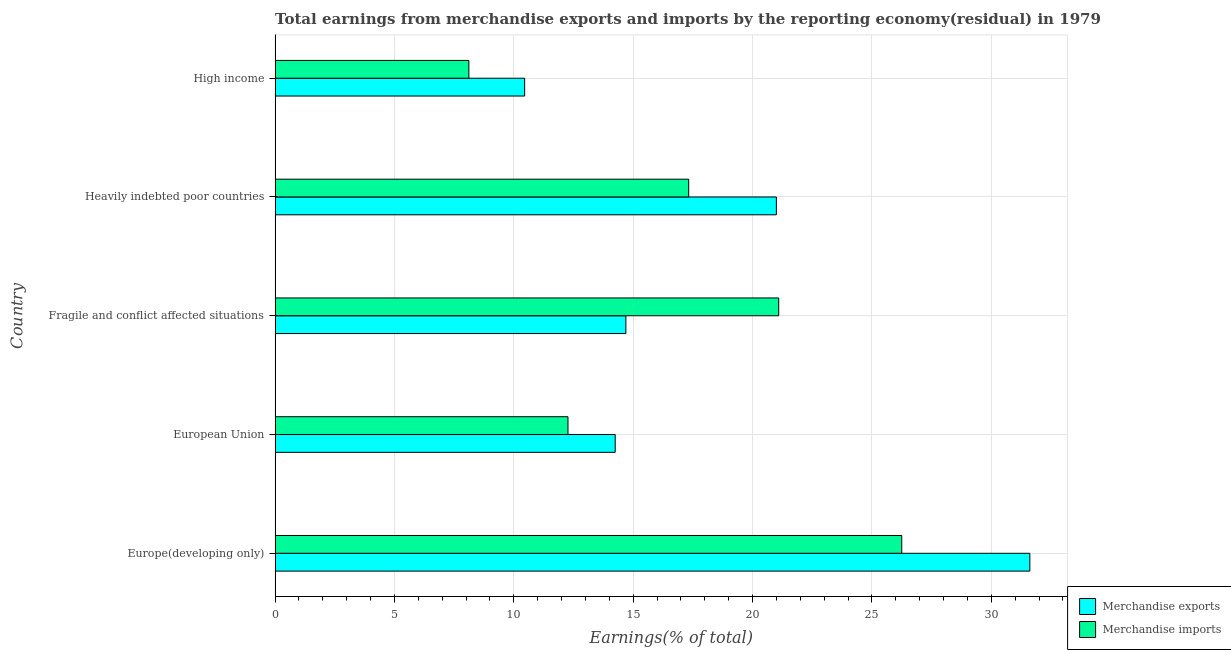How many groups of bars are there?
Offer a very short reply. 5. How many bars are there on the 2nd tick from the top?
Your answer should be compact. 2. How many bars are there on the 3rd tick from the bottom?
Ensure brevity in your answer.  2. What is the label of the 3rd group of bars from the top?
Your answer should be compact. Fragile and conflict affected situations. What is the earnings from merchandise exports in Heavily indebted poor countries?
Provide a succinct answer. 21. Across all countries, what is the maximum earnings from merchandise exports?
Your response must be concise. 31.62. Across all countries, what is the minimum earnings from merchandise exports?
Your answer should be very brief. 10.45. In which country was the earnings from merchandise exports maximum?
Ensure brevity in your answer.  Europe(developing only). What is the total earnings from merchandise imports in the graph?
Your answer should be very brief. 85.06. What is the difference between the earnings from merchandise exports in European Union and that in Heavily indebted poor countries?
Keep it short and to the point. -6.75. What is the difference between the earnings from merchandise exports in High income and the earnings from merchandise imports in Fragile and conflict affected situations?
Your answer should be compact. -10.64. What is the average earnings from merchandise imports per country?
Offer a very short reply. 17.01. What is the difference between the earnings from merchandise exports and earnings from merchandise imports in European Union?
Provide a succinct answer. 1.98. What is the ratio of the earnings from merchandise imports in Europe(developing only) to that in European Union?
Your response must be concise. 2.14. What is the difference between the highest and the second highest earnings from merchandise exports?
Provide a succinct answer. 10.62. What is the difference between the highest and the lowest earnings from merchandise imports?
Ensure brevity in your answer.  18.13. How many countries are there in the graph?
Make the answer very short. 5. Are the values on the major ticks of X-axis written in scientific E-notation?
Provide a succinct answer. No. How are the legend labels stacked?
Offer a very short reply. Vertical. What is the title of the graph?
Make the answer very short. Total earnings from merchandise exports and imports by the reporting economy(residual) in 1979. Does "Electricity" appear as one of the legend labels in the graph?
Give a very brief answer. No. What is the label or title of the X-axis?
Your answer should be compact. Earnings(% of total). What is the Earnings(% of total) of Merchandise exports in Europe(developing only)?
Your answer should be very brief. 31.62. What is the Earnings(% of total) in Merchandise imports in Europe(developing only)?
Your answer should be very brief. 26.25. What is the Earnings(% of total) of Merchandise exports in European Union?
Give a very brief answer. 14.25. What is the Earnings(% of total) in Merchandise imports in European Union?
Your answer should be compact. 12.27. What is the Earnings(% of total) in Merchandise exports in Fragile and conflict affected situations?
Keep it short and to the point. 14.69. What is the Earnings(% of total) of Merchandise imports in Fragile and conflict affected situations?
Your answer should be compact. 21.1. What is the Earnings(% of total) of Merchandise exports in Heavily indebted poor countries?
Offer a terse response. 21. What is the Earnings(% of total) in Merchandise imports in Heavily indebted poor countries?
Offer a terse response. 17.33. What is the Earnings(% of total) in Merchandise exports in High income?
Keep it short and to the point. 10.45. What is the Earnings(% of total) in Merchandise imports in High income?
Ensure brevity in your answer.  8.12. Across all countries, what is the maximum Earnings(% of total) of Merchandise exports?
Your response must be concise. 31.62. Across all countries, what is the maximum Earnings(% of total) in Merchandise imports?
Keep it short and to the point. 26.25. Across all countries, what is the minimum Earnings(% of total) in Merchandise exports?
Keep it short and to the point. 10.45. Across all countries, what is the minimum Earnings(% of total) of Merchandise imports?
Keep it short and to the point. 8.12. What is the total Earnings(% of total) in Merchandise exports in the graph?
Keep it short and to the point. 92.01. What is the total Earnings(% of total) of Merchandise imports in the graph?
Your answer should be compact. 85.06. What is the difference between the Earnings(% of total) in Merchandise exports in Europe(developing only) and that in European Union?
Your response must be concise. 17.37. What is the difference between the Earnings(% of total) in Merchandise imports in Europe(developing only) and that in European Union?
Provide a succinct answer. 13.98. What is the difference between the Earnings(% of total) of Merchandise exports in Europe(developing only) and that in Fragile and conflict affected situations?
Your response must be concise. 16.92. What is the difference between the Earnings(% of total) of Merchandise imports in Europe(developing only) and that in Fragile and conflict affected situations?
Keep it short and to the point. 5.15. What is the difference between the Earnings(% of total) in Merchandise exports in Europe(developing only) and that in Heavily indebted poor countries?
Your answer should be very brief. 10.62. What is the difference between the Earnings(% of total) of Merchandise imports in Europe(developing only) and that in Heavily indebted poor countries?
Make the answer very short. 8.92. What is the difference between the Earnings(% of total) of Merchandise exports in Europe(developing only) and that in High income?
Offer a very short reply. 21.16. What is the difference between the Earnings(% of total) in Merchandise imports in Europe(developing only) and that in High income?
Offer a very short reply. 18.13. What is the difference between the Earnings(% of total) of Merchandise exports in European Union and that in Fragile and conflict affected situations?
Make the answer very short. -0.45. What is the difference between the Earnings(% of total) of Merchandise imports in European Union and that in Fragile and conflict affected situations?
Provide a succinct answer. -8.83. What is the difference between the Earnings(% of total) in Merchandise exports in European Union and that in Heavily indebted poor countries?
Ensure brevity in your answer.  -6.75. What is the difference between the Earnings(% of total) in Merchandise imports in European Union and that in Heavily indebted poor countries?
Ensure brevity in your answer.  -5.06. What is the difference between the Earnings(% of total) of Merchandise exports in European Union and that in High income?
Make the answer very short. 3.79. What is the difference between the Earnings(% of total) of Merchandise imports in European Union and that in High income?
Keep it short and to the point. 4.15. What is the difference between the Earnings(% of total) in Merchandise exports in Fragile and conflict affected situations and that in Heavily indebted poor countries?
Your answer should be compact. -6.3. What is the difference between the Earnings(% of total) of Merchandise imports in Fragile and conflict affected situations and that in Heavily indebted poor countries?
Offer a very short reply. 3.77. What is the difference between the Earnings(% of total) of Merchandise exports in Fragile and conflict affected situations and that in High income?
Make the answer very short. 4.24. What is the difference between the Earnings(% of total) of Merchandise imports in Fragile and conflict affected situations and that in High income?
Give a very brief answer. 12.98. What is the difference between the Earnings(% of total) of Merchandise exports in Heavily indebted poor countries and that in High income?
Keep it short and to the point. 10.55. What is the difference between the Earnings(% of total) of Merchandise imports in Heavily indebted poor countries and that in High income?
Provide a short and direct response. 9.21. What is the difference between the Earnings(% of total) in Merchandise exports in Europe(developing only) and the Earnings(% of total) in Merchandise imports in European Union?
Your answer should be very brief. 19.35. What is the difference between the Earnings(% of total) of Merchandise exports in Europe(developing only) and the Earnings(% of total) of Merchandise imports in Fragile and conflict affected situations?
Your answer should be very brief. 10.52. What is the difference between the Earnings(% of total) of Merchandise exports in Europe(developing only) and the Earnings(% of total) of Merchandise imports in Heavily indebted poor countries?
Your response must be concise. 14.29. What is the difference between the Earnings(% of total) in Merchandise exports in Europe(developing only) and the Earnings(% of total) in Merchandise imports in High income?
Offer a terse response. 23.5. What is the difference between the Earnings(% of total) of Merchandise exports in European Union and the Earnings(% of total) of Merchandise imports in Fragile and conflict affected situations?
Provide a succinct answer. -6.85. What is the difference between the Earnings(% of total) of Merchandise exports in European Union and the Earnings(% of total) of Merchandise imports in Heavily indebted poor countries?
Ensure brevity in your answer.  -3.08. What is the difference between the Earnings(% of total) in Merchandise exports in European Union and the Earnings(% of total) in Merchandise imports in High income?
Your answer should be compact. 6.13. What is the difference between the Earnings(% of total) of Merchandise exports in Fragile and conflict affected situations and the Earnings(% of total) of Merchandise imports in Heavily indebted poor countries?
Your response must be concise. -2.63. What is the difference between the Earnings(% of total) of Merchandise exports in Fragile and conflict affected situations and the Earnings(% of total) of Merchandise imports in High income?
Offer a terse response. 6.58. What is the difference between the Earnings(% of total) in Merchandise exports in Heavily indebted poor countries and the Earnings(% of total) in Merchandise imports in High income?
Ensure brevity in your answer.  12.88. What is the average Earnings(% of total) of Merchandise exports per country?
Make the answer very short. 18.4. What is the average Earnings(% of total) of Merchandise imports per country?
Provide a short and direct response. 17.01. What is the difference between the Earnings(% of total) of Merchandise exports and Earnings(% of total) of Merchandise imports in Europe(developing only)?
Your answer should be compact. 5.37. What is the difference between the Earnings(% of total) in Merchandise exports and Earnings(% of total) in Merchandise imports in European Union?
Your response must be concise. 1.98. What is the difference between the Earnings(% of total) in Merchandise exports and Earnings(% of total) in Merchandise imports in Fragile and conflict affected situations?
Make the answer very short. -6.4. What is the difference between the Earnings(% of total) in Merchandise exports and Earnings(% of total) in Merchandise imports in Heavily indebted poor countries?
Make the answer very short. 3.67. What is the difference between the Earnings(% of total) in Merchandise exports and Earnings(% of total) in Merchandise imports in High income?
Provide a short and direct response. 2.34. What is the ratio of the Earnings(% of total) of Merchandise exports in Europe(developing only) to that in European Union?
Make the answer very short. 2.22. What is the ratio of the Earnings(% of total) in Merchandise imports in Europe(developing only) to that in European Union?
Keep it short and to the point. 2.14. What is the ratio of the Earnings(% of total) in Merchandise exports in Europe(developing only) to that in Fragile and conflict affected situations?
Provide a short and direct response. 2.15. What is the ratio of the Earnings(% of total) in Merchandise imports in Europe(developing only) to that in Fragile and conflict affected situations?
Provide a succinct answer. 1.24. What is the ratio of the Earnings(% of total) in Merchandise exports in Europe(developing only) to that in Heavily indebted poor countries?
Your response must be concise. 1.51. What is the ratio of the Earnings(% of total) in Merchandise imports in Europe(developing only) to that in Heavily indebted poor countries?
Provide a succinct answer. 1.52. What is the ratio of the Earnings(% of total) of Merchandise exports in Europe(developing only) to that in High income?
Your answer should be very brief. 3.02. What is the ratio of the Earnings(% of total) in Merchandise imports in Europe(developing only) to that in High income?
Provide a succinct answer. 3.23. What is the ratio of the Earnings(% of total) of Merchandise exports in European Union to that in Fragile and conflict affected situations?
Provide a succinct answer. 0.97. What is the ratio of the Earnings(% of total) in Merchandise imports in European Union to that in Fragile and conflict affected situations?
Make the answer very short. 0.58. What is the ratio of the Earnings(% of total) in Merchandise exports in European Union to that in Heavily indebted poor countries?
Give a very brief answer. 0.68. What is the ratio of the Earnings(% of total) of Merchandise imports in European Union to that in Heavily indebted poor countries?
Your response must be concise. 0.71. What is the ratio of the Earnings(% of total) of Merchandise exports in European Union to that in High income?
Ensure brevity in your answer.  1.36. What is the ratio of the Earnings(% of total) in Merchandise imports in European Union to that in High income?
Offer a very short reply. 1.51. What is the ratio of the Earnings(% of total) of Merchandise exports in Fragile and conflict affected situations to that in Heavily indebted poor countries?
Your answer should be very brief. 0.7. What is the ratio of the Earnings(% of total) in Merchandise imports in Fragile and conflict affected situations to that in Heavily indebted poor countries?
Provide a succinct answer. 1.22. What is the ratio of the Earnings(% of total) in Merchandise exports in Fragile and conflict affected situations to that in High income?
Your answer should be very brief. 1.41. What is the ratio of the Earnings(% of total) of Merchandise imports in Fragile and conflict affected situations to that in High income?
Keep it short and to the point. 2.6. What is the ratio of the Earnings(% of total) of Merchandise exports in Heavily indebted poor countries to that in High income?
Provide a succinct answer. 2.01. What is the ratio of the Earnings(% of total) in Merchandise imports in Heavily indebted poor countries to that in High income?
Make the answer very short. 2.13. What is the difference between the highest and the second highest Earnings(% of total) in Merchandise exports?
Make the answer very short. 10.62. What is the difference between the highest and the second highest Earnings(% of total) in Merchandise imports?
Ensure brevity in your answer.  5.15. What is the difference between the highest and the lowest Earnings(% of total) in Merchandise exports?
Keep it short and to the point. 21.16. What is the difference between the highest and the lowest Earnings(% of total) in Merchandise imports?
Offer a terse response. 18.13. 